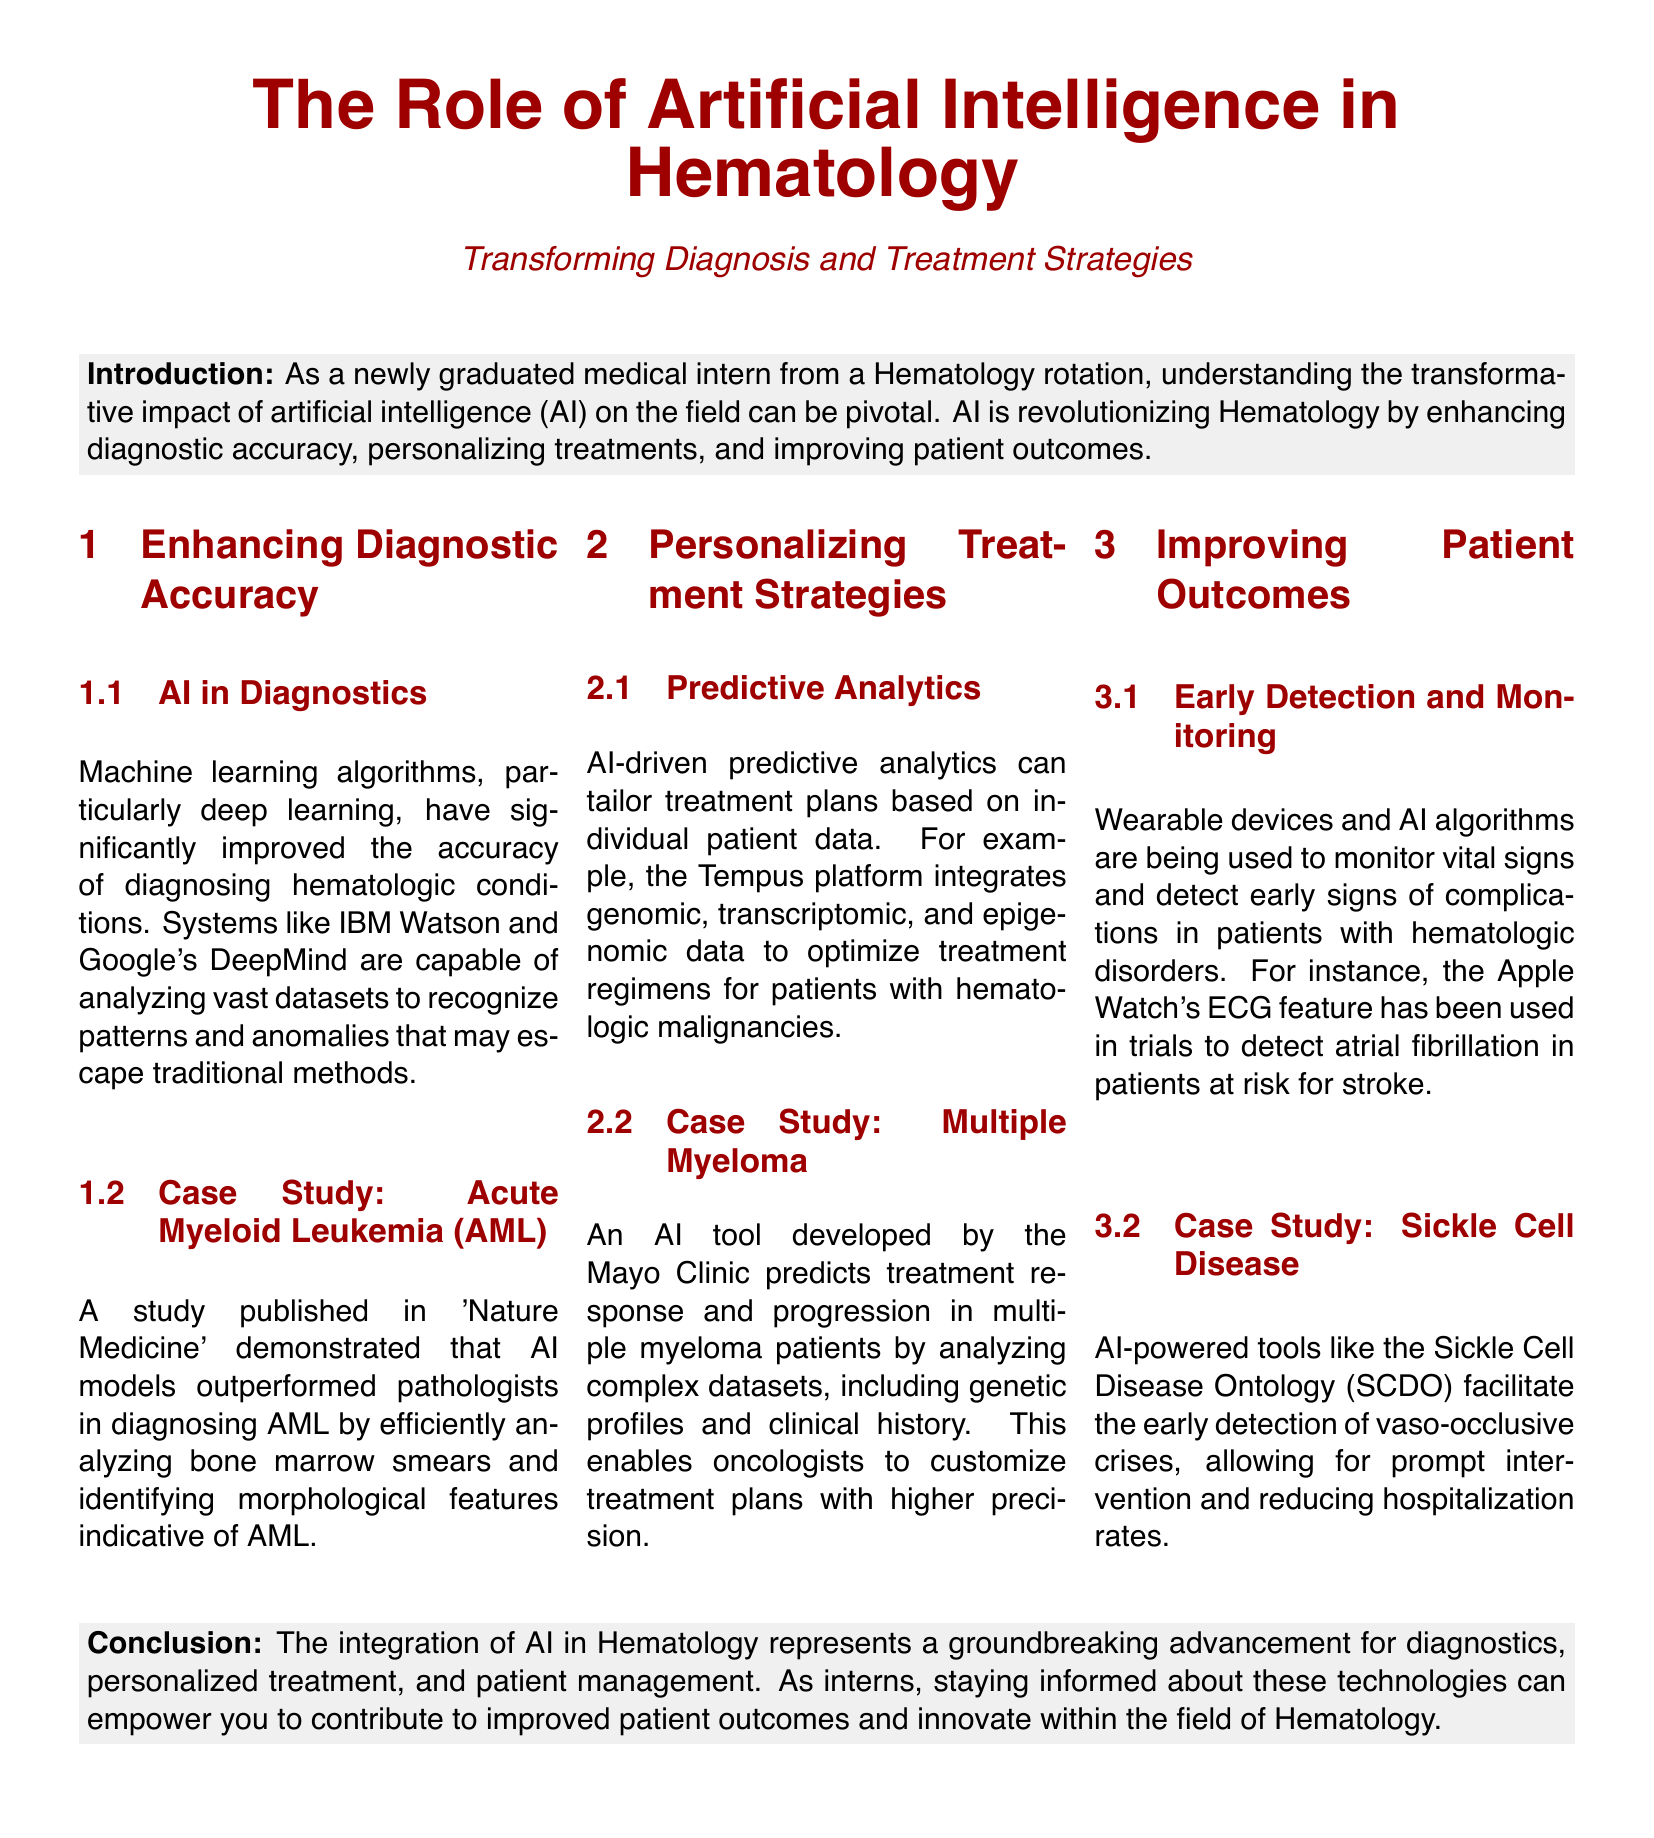What is the primary focus of the document? The document focuses on the role of artificial intelligence in transforming diagnosis and treatment strategies in Hematology.
Answer: Artificial Intelligence in Hematology Which two AI systems are mentioned for enhancing diagnostic accuracy? The document lists IBM Watson and Google's DeepMind as examples of AI systems improving diagnostic accuracy.
Answer: IBM Watson and Google's DeepMind What hematologic condition is specifically mentioned in a case study for diagnostic improvement? The case study highlighted in the document focuses on Acute Myeloid Leukemia (AML) for diagnostic enhancement.
Answer: Acute Myeloid Leukemia (AML) What platform integrates genomic data for personalizing treatment? The Tempus platform is mentioned as integrating genomic, transcriptomic, and epigenomic data for optimizing treatment plans.
Answer: Tempus platform Which wearable device is mentioned for early detection in hematologic disorders? The document references the Apple Watch's ECG feature as a tool used for early detection of complications in hematologic disorders.
Answer: Apple Watch What is the primary outcome of using AI-powered tools in Sickle Cell Disease? The AI-powered tools facilitate early detection of vaso-occlusive crises, prompting timely interventions and reducing hospitalizations.
Answer: Early detection of vaso-occlusive crises What is the conclusion of the document regarding AI in Hematology? The conclusion emphasizes that the integration of AI represents a groundbreaking advancement for diagnostics, personalized treatment, and patient management.
Answer: Groundbreaking advancement In which publication was the case study about AI models diagnosing AML published? The case study regarding AI models diagnosing AML was published in 'Nature Medicine'.
Answer: Nature Medicine 